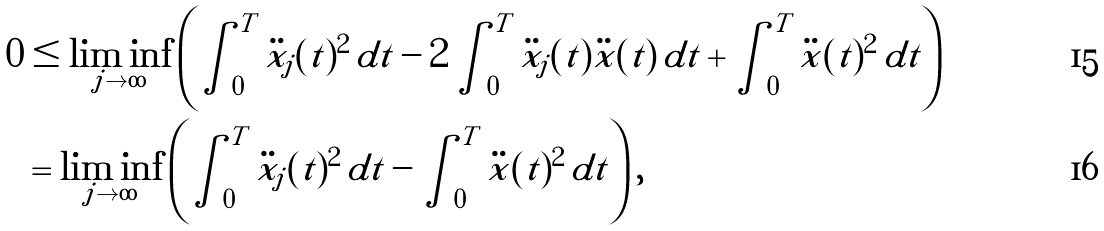<formula> <loc_0><loc_0><loc_500><loc_500>0 & \leq \liminf _ { j \to \infty } \left ( \int _ { 0 } ^ { T } \ddot { x } _ { j } ( t ) ^ { 2 } \, d t - 2 \int _ { 0 } ^ { T } \ddot { x } _ { j } ( t ) \ddot { x } ( t ) \, d t + \int _ { 0 } ^ { T } \ddot { x } ( t ) ^ { 2 } \, d t \right ) \\ & = \liminf _ { j \to \infty } \left ( \int _ { 0 } ^ { T } \ddot { x } _ { j } ( t ) ^ { 2 } \, d t - \int _ { 0 } ^ { T } \ddot { x } ( t ) ^ { 2 } \, d t \right ) ,</formula> 